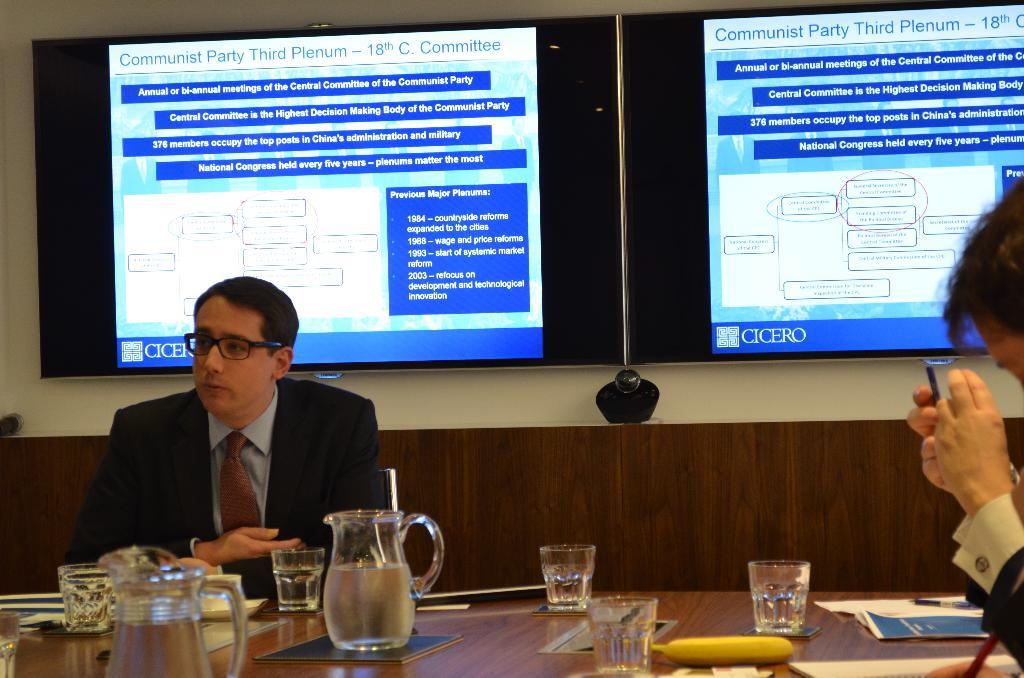What political party is mentioned on the slides?
Give a very brief answer. Communist. 